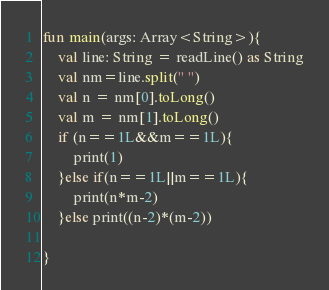<code> <loc_0><loc_0><loc_500><loc_500><_Kotlin_>fun main(args: Array<String>){
    val line: String = readLine() as String
    val nm=line.split(" ")
    val n = nm[0].toLong()
    val m = nm[1].toLong()
    if (n==1L&&m==1L){
        print(1)
    }else if(n==1L||m==1L){
        print(n*m-2)
    }else print((n-2)*(m-2))

}</code> 